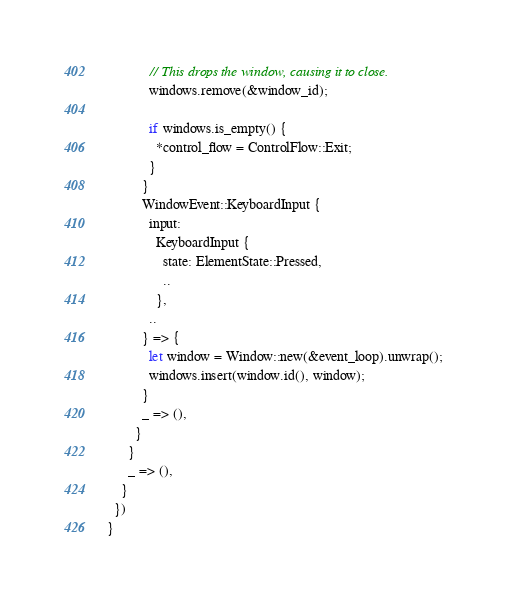<code> <loc_0><loc_0><loc_500><loc_500><_Rust_>            // This drops the window, causing it to close.
            windows.remove(&window_id);

            if windows.is_empty() {
              *control_flow = ControlFlow::Exit;
            }
          }
          WindowEvent::KeyboardInput {
            input:
              KeyboardInput {
                state: ElementState::Pressed,
                ..
              },
            ..
          } => {
            let window = Window::new(&event_loop).unwrap();
            windows.insert(window.id(), window);
          }
          _ => (),
        }
      }
      _ => (),
    }
  })
}
</code> 